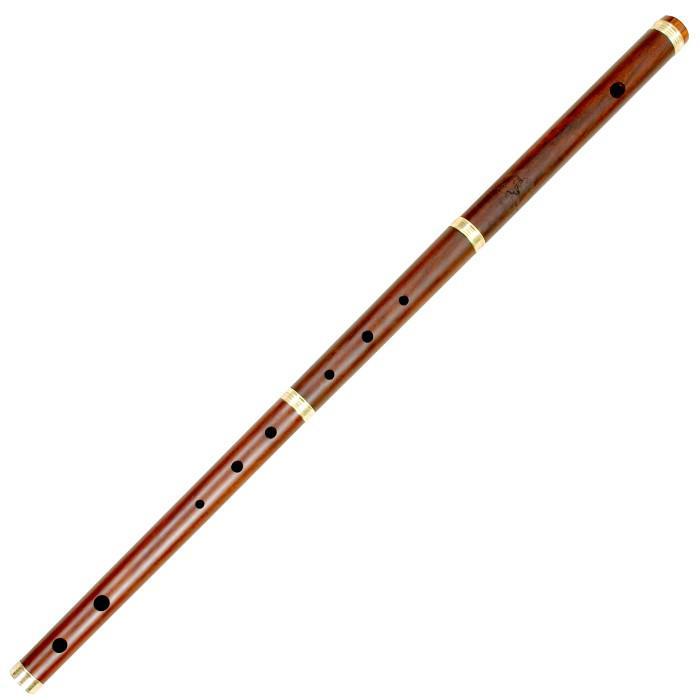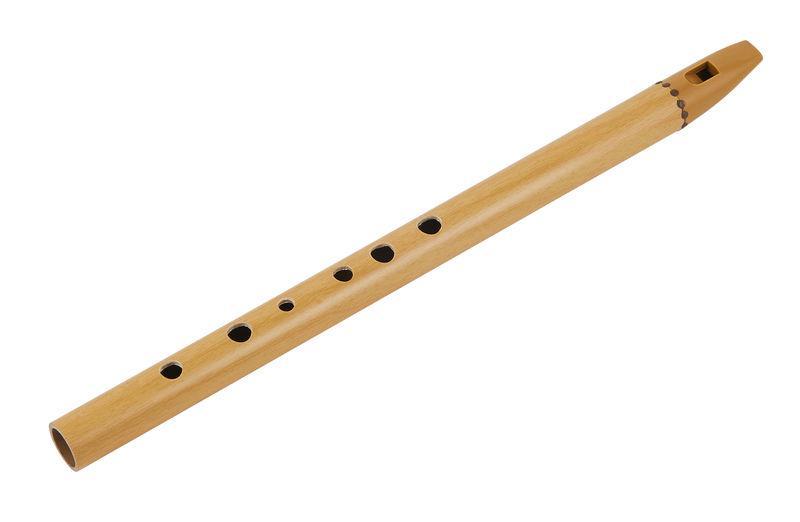The first image is the image on the left, the second image is the image on the right. Assess this claim about the two images: "There are exactly two flutes.". Correct or not? Answer yes or no. Yes. The first image is the image on the left, the second image is the image on the right. Assess this claim about the two images: "One image contains at least two flute sticks positioned with one end together and the other end fanning out.". Correct or not? Answer yes or no. No. 